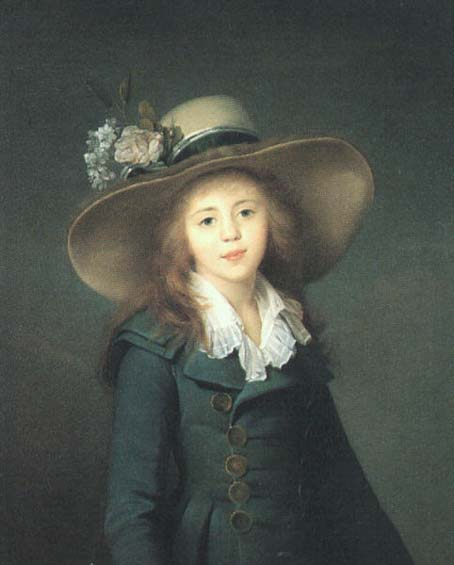How does the lighting in the portrait affect the mood or perception of the character? The soft, diffuse lighting in the portrait gently illuminates the girl’s face and attire, creating a serene and contemplative mood. It enhances her youthful features and the texture of the materials, such as the glossy gold buttons and the soft petals of the flowers, lending an almost ethereal quality to the scene. This type of lighting evokes a sense of innocence and the refined elegance associated with classical portraiture. 